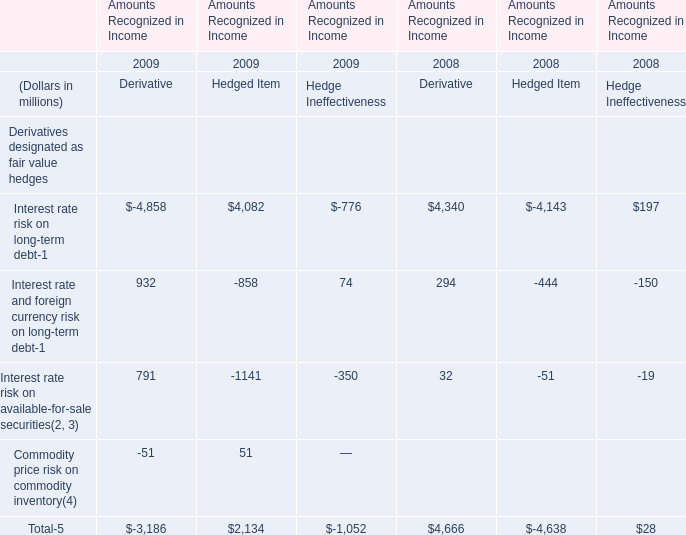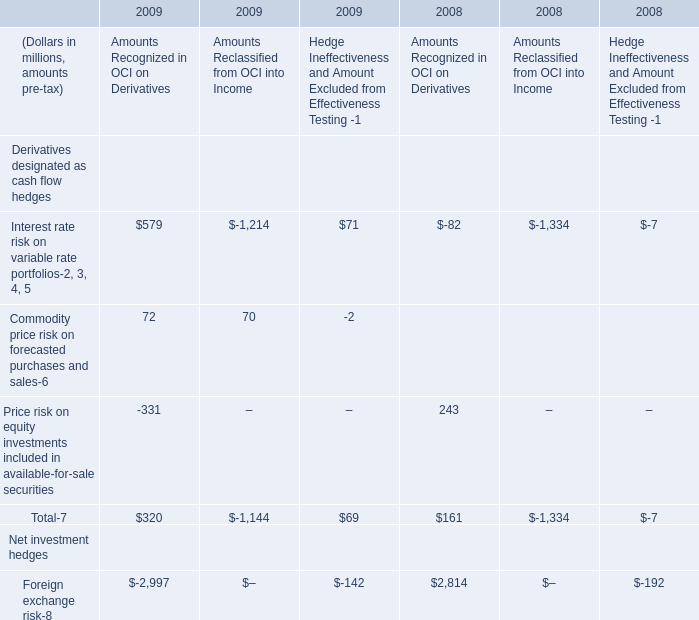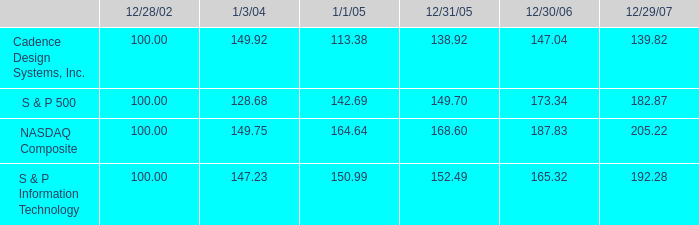In the year with lowest amount of Interest rate risk on long-term debt, what's the increasing rate of Interest rate and foreign currency risk on long-term debt? 
Computations: ((((932 - 858) + 74) - ((294 - 444) - 150)) / ((294 - 444) - 150))
Answer: -1.49333. 